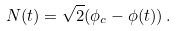<formula> <loc_0><loc_0><loc_500><loc_500>N ( t ) = \sqrt { 2 } ( \phi _ { c } - \phi ( t ) ) \, .</formula> 